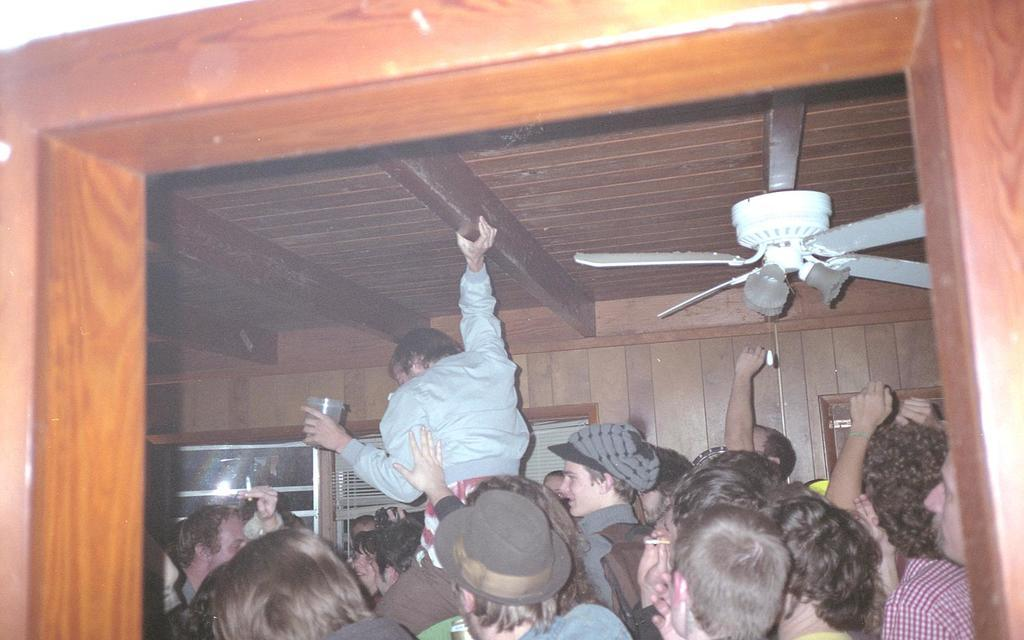How many people are in the image? There is a group of persons in the image. Where are the persons located in the image? The persons are on the floor. What can be seen in the background of the image? There is a wall, windows, a curtain, and a fan in the background of the image. What type of fiction is the son reading in the image? There is no son or book present in the image, so it is not possible to determine what type of fiction might be read. 